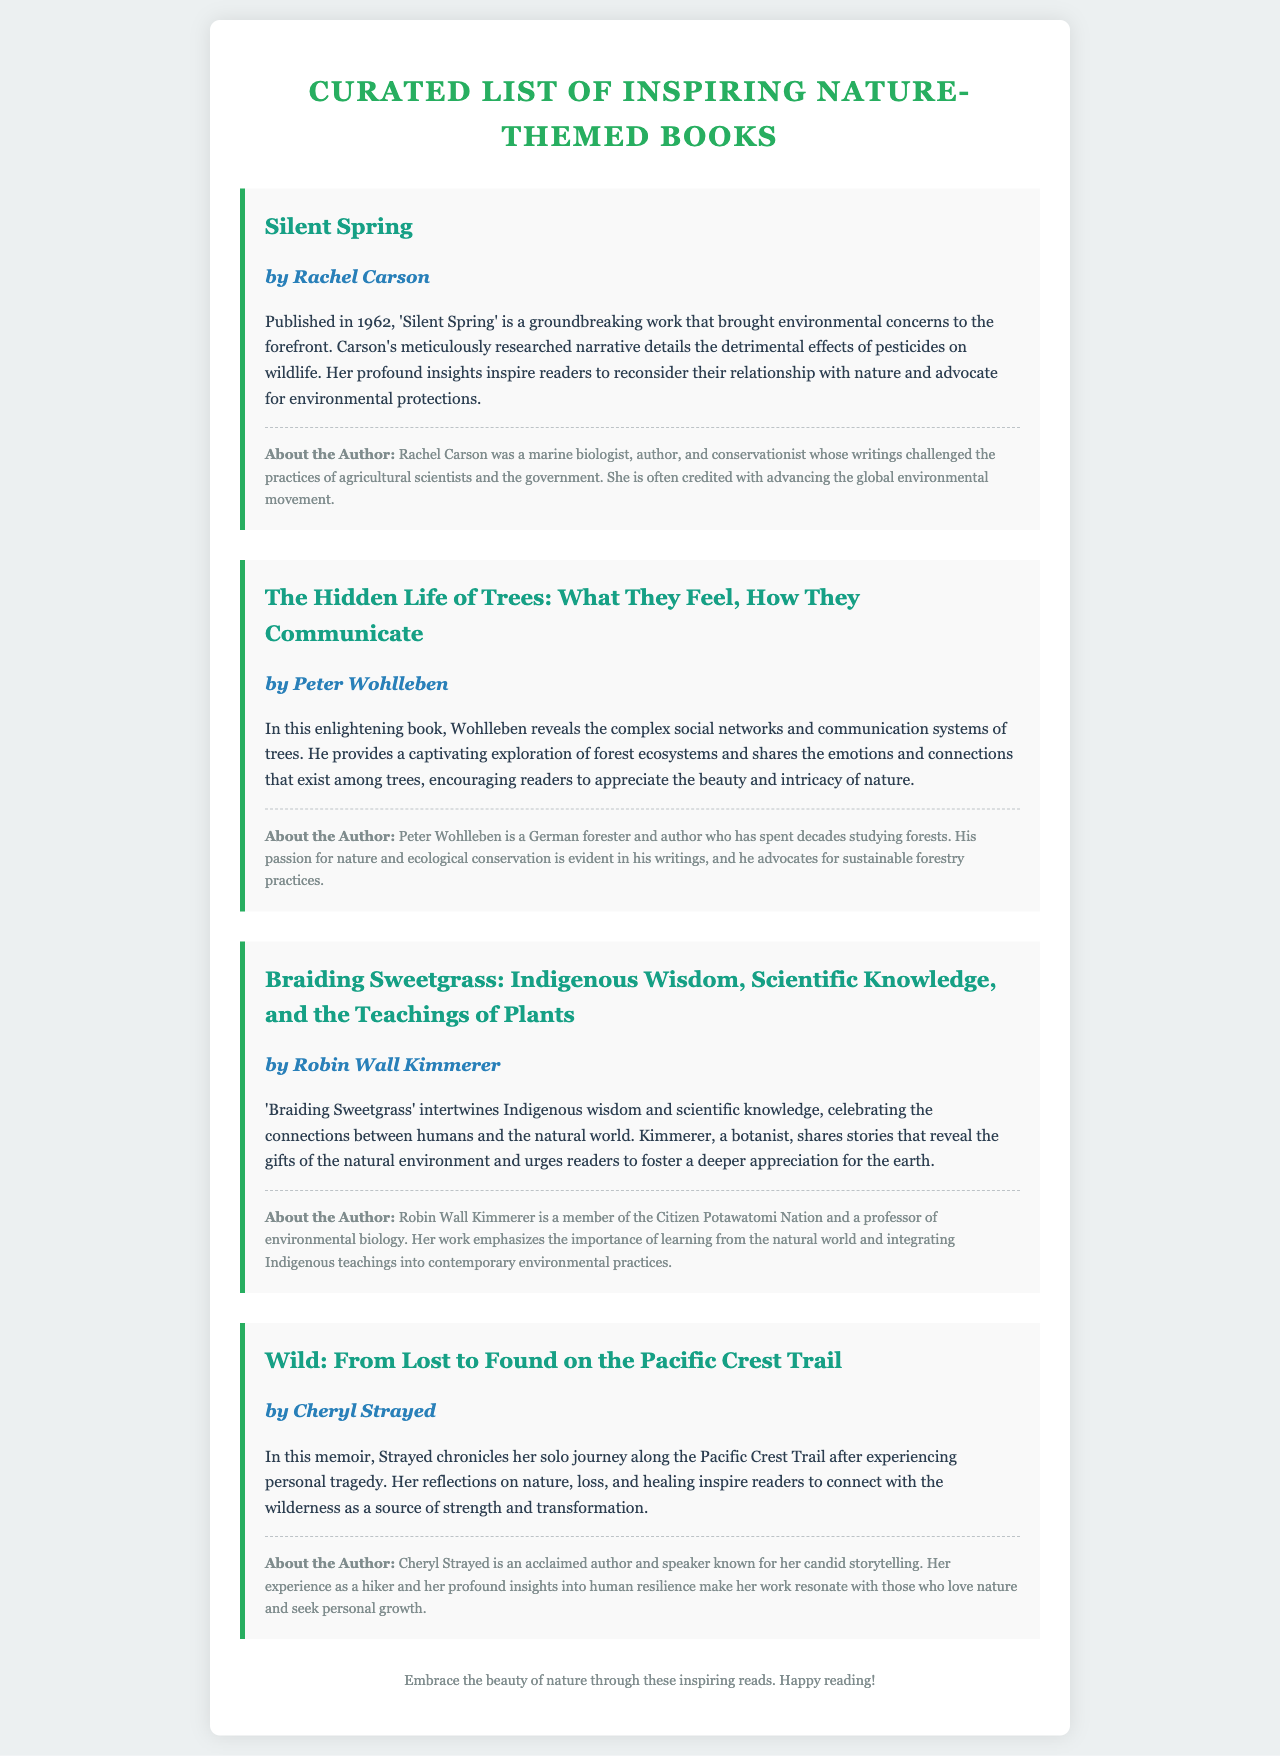What is the title of the first book listed? The title of the first book is found in the book section, which lists the works included in the curated list.
Answer: Silent Spring Who is the author of "Braiding Sweetgrass"? The author's name is provided in association with their respective book titles throughout the document.
Answer: Robin Wall Kimmerer In what year was "Silent Spring" published? The year of publication is mentioned in the summary of each book, providing historical context for the work.
Answer: 1962 What is the main theme of "The Hidden Life of Trees"? The thematic focus of each book is described in their individual summaries, highlighting the key concepts the authors explore.
Answer: Communication systems of trees Who is the author of "Wild: From Lost to Found on the Pacific Crest Trail"? This question aims to identify the writer of a specific book based on the listing provided in the document.
Answer: Cheryl Strayed What profession is Robin Wall Kimmerer known for? The author background typically includes relevant professions, education, or roles of the authors, lending credibility to their writings.
Answer: Professor of environmental biology What is the overarching message of "Braiding Sweetgrass"? The summaries provide insight into the deeper meanings and lessons conveyed in each book, offering a broader understanding of their significance.
Answer: Appreciation for the earth What aesthetic style is used for the document? The design choices and thematic elements are detailed in the style section of the HTML code, which determines the look and feel of the document.
Answer: Nature-themed How many books are included in the curated list? The number of books can be counted from the individual book sections within the document that represent each entry.
Answer: Four 